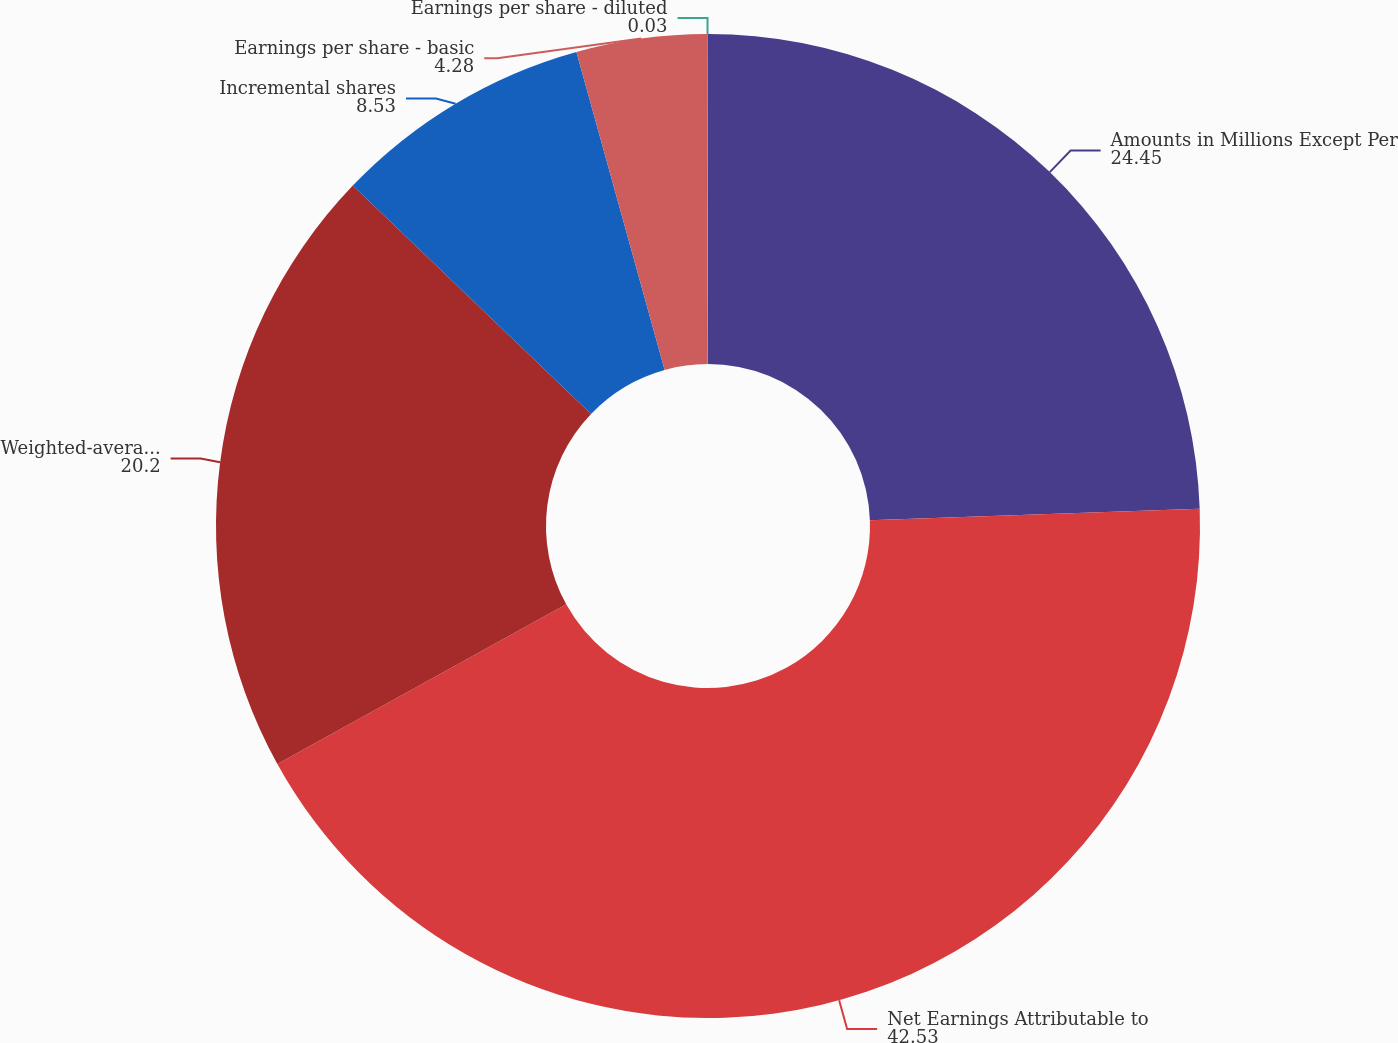Convert chart to OTSL. <chart><loc_0><loc_0><loc_500><loc_500><pie_chart><fcel>Amounts in Millions Except Per<fcel>Net Earnings Attributable to<fcel>Weighted-average common shares<fcel>Incremental shares<fcel>Earnings per share - basic<fcel>Earnings per share - diluted<nl><fcel>24.45%<fcel>42.53%<fcel>20.2%<fcel>8.53%<fcel>4.28%<fcel>0.03%<nl></chart> 